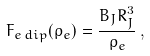Convert formula to latex. <formula><loc_0><loc_0><loc_500><loc_500>F _ { e \, d i p } ( \rho _ { e } ) = \frac { B _ { J } R _ { J } ^ { 3 } } { { \rho _ { e } } } \, ,</formula> 